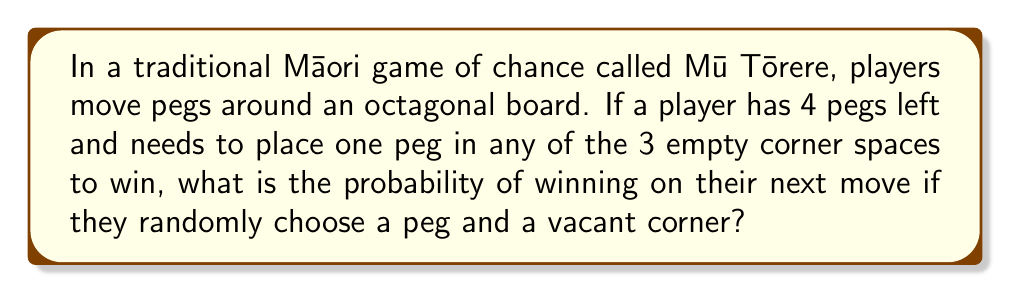Provide a solution to this math problem. Let's approach this step-by-step:

1) First, we need to determine the total number of possible outcomes. This is the product of:
   - The number of ways to choose a peg (4 choices)
   - The number of ways to choose an empty corner (3 choices)

   Total outcomes = $4 \times 3 = 12$

2) Now, we need to determine the number of favorable outcomes. A favorable outcome occurs when the chosen peg can legally move to the chosen corner.

3) In Mū Tōrere, a peg can only move to an adjacent empty space. Given that there are 4 pegs and 3 empty corners, at most 2 pegs can be adjacent to empty corners.

4) Therefore, the number of favorable outcomes is at most $2 \times 3 = 6$ (if 2 pegs can move, each to any of the 3 corners).

5) The probability is then:

   $$P(\text{winning}) = \frac{\text{favorable outcomes}}{\text{total outcomes}} = \frac{6}{12} = \frac{1}{2}$$

6) However, this is an upper bound. The actual probability might be lower depending on the specific arrangement of the pegs on the board.
Answer: $\frac{1}{2}$ or less 